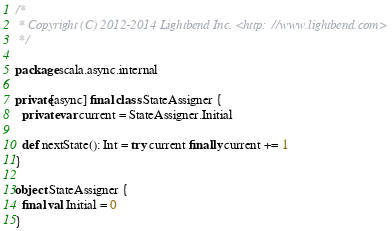Convert code to text. <code><loc_0><loc_0><loc_500><loc_500><_Scala_>/*
 * Copyright (C) 2012-2014 Lightbend Inc. <http://www.lightbend.com>
 */

package scala.async.internal

private[async] final class StateAssigner {
  private var current = StateAssigner.Initial

  def nextState(): Int = try current finally current += 1
}

object StateAssigner {
  final val Initial = 0
}</code> 